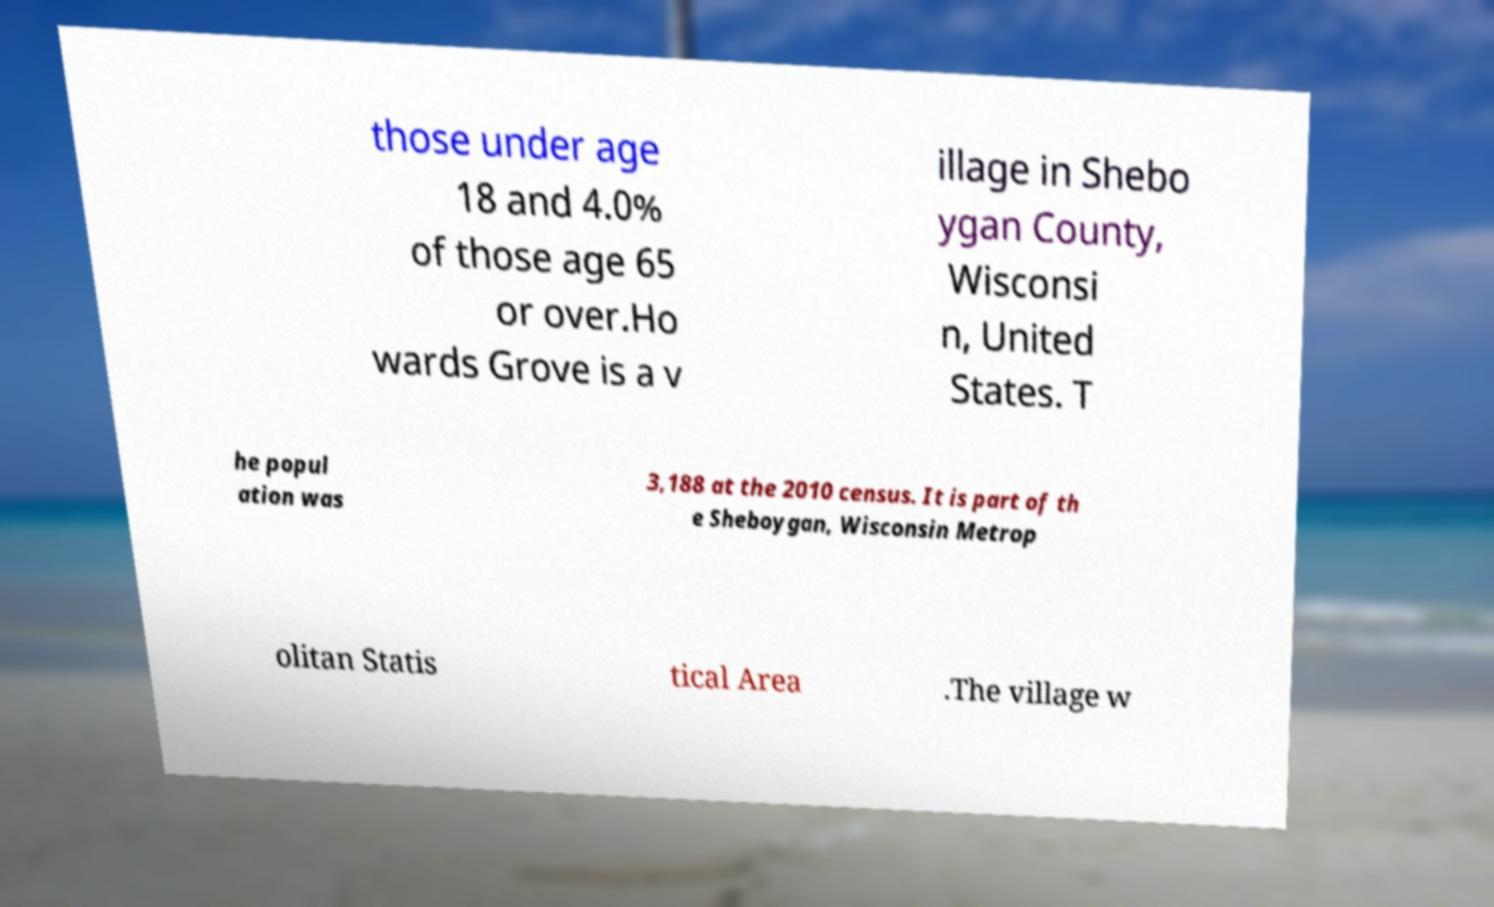Please identify and transcribe the text found in this image. those under age 18 and 4.0% of those age 65 or over.Ho wards Grove is a v illage in Shebo ygan County, Wisconsi n, United States. T he popul ation was 3,188 at the 2010 census. It is part of th e Sheboygan, Wisconsin Metrop olitan Statis tical Area .The village w 